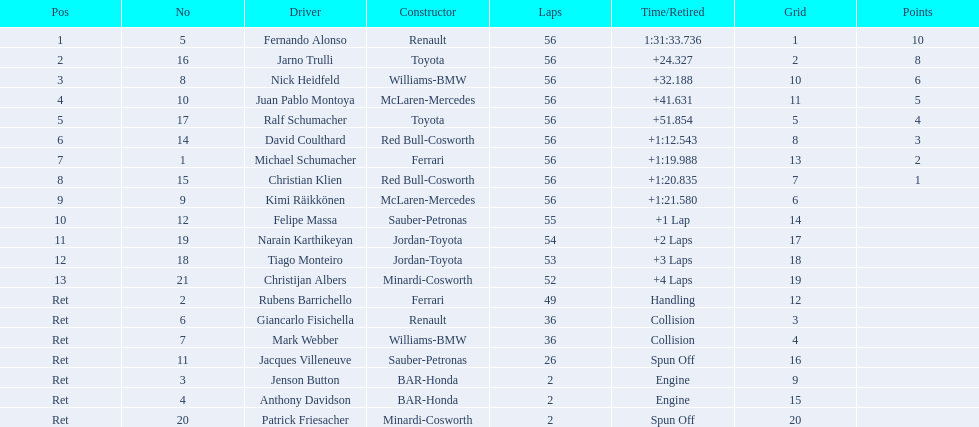Could you help me parse every detail presented in this table? {'header': ['Pos', 'No', 'Driver', 'Constructor', 'Laps', 'Time/Retired', 'Grid', 'Points'], 'rows': [['1', '5', 'Fernando Alonso', 'Renault', '56', '1:31:33.736', '1', '10'], ['2', '16', 'Jarno Trulli', 'Toyota', '56', '+24.327', '2', '8'], ['3', '8', 'Nick Heidfeld', 'Williams-BMW', '56', '+32.188', '10', '6'], ['4', '10', 'Juan Pablo Montoya', 'McLaren-Mercedes', '56', '+41.631', '11', '5'], ['5', '17', 'Ralf Schumacher', 'Toyota', '56', '+51.854', '5', '4'], ['6', '14', 'David Coulthard', 'Red Bull-Cosworth', '56', '+1:12.543', '8', '3'], ['7', '1', 'Michael Schumacher', 'Ferrari', '56', '+1:19.988', '13', '2'], ['8', '15', 'Christian Klien', 'Red Bull-Cosworth', '56', '+1:20.835', '7', '1'], ['9', '9', 'Kimi Räikkönen', 'McLaren-Mercedes', '56', '+1:21.580', '6', ''], ['10', '12', 'Felipe Massa', 'Sauber-Petronas', '55', '+1 Lap', '14', ''], ['11', '19', 'Narain Karthikeyan', 'Jordan-Toyota', '54', '+2 Laps', '17', ''], ['12', '18', 'Tiago Monteiro', 'Jordan-Toyota', '53', '+3 Laps', '18', ''], ['13', '21', 'Christijan Albers', 'Minardi-Cosworth', '52', '+4 Laps', '19', ''], ['Ret', '2', 'Rubens Barrichello', 'Ferrari', '49', 'Handling', '12', ''], ['Ret', '6', 'Giancarlo Fisichella', 'Renault', '36', 'Collision', '3', ''], ['Ret', '7', 'Mark Webber', 'Williams-BMW', '36', 'Collision', '4', ''], ['Ret', '11', 'Jacques Villeneuve', 'Sauber-Petronas', '26', 'Spun Off', '16', ''], ['Ret', '3', 'Jenson Button', 'BAR-Honda', '2', 'Engine', '9', ''], ['Ret', '4', 'Anthony Davidson', 'BAR-Honda', '2', 'Engine', '15', ''], ['Ret', '20', 'Patrick Friesacher', 'Minardi-Cosworth', '2', 'Spun Off', '20', '']]} How many germans completed in the top five? 2. 